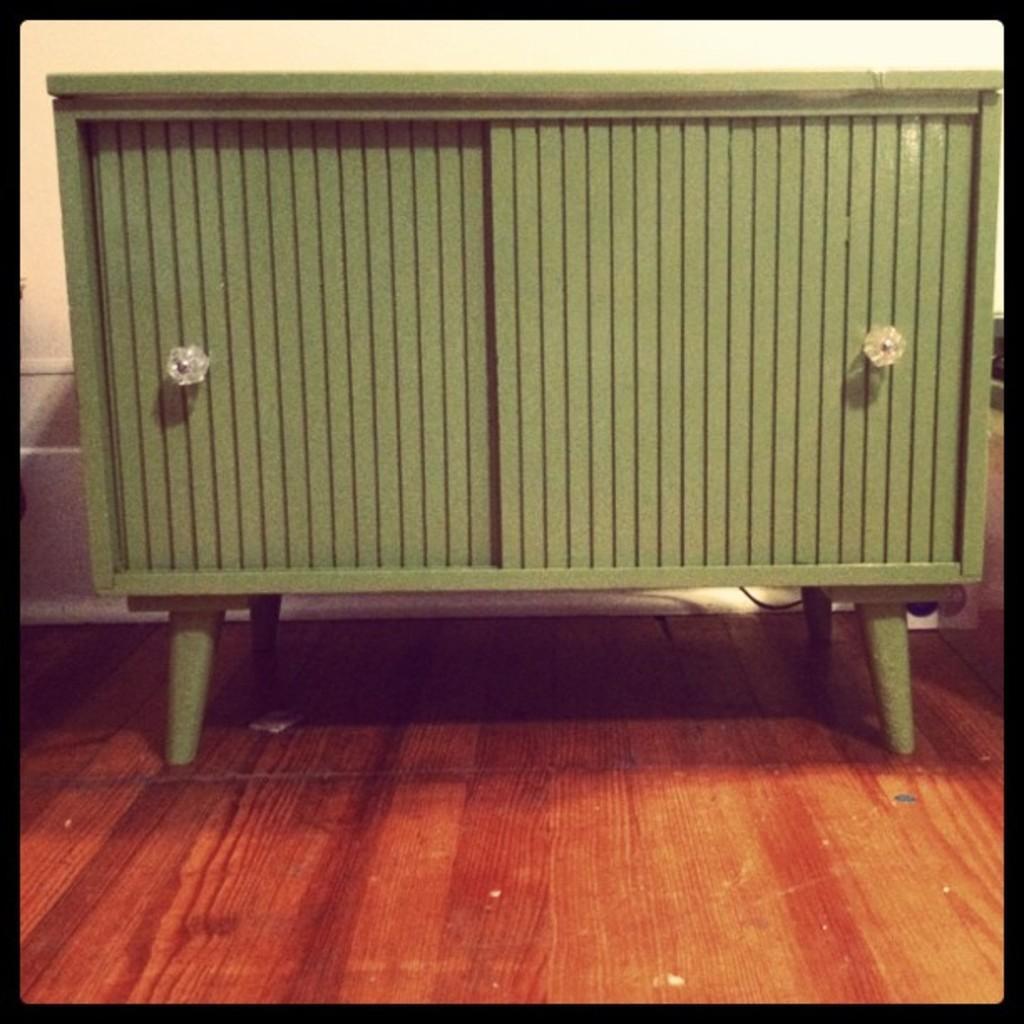How would you summarize this image in a sentence or two? In the center of the image we can see a cupboard. In the background of the image we can see the wall. At the bottom of the image we can see the floor. 